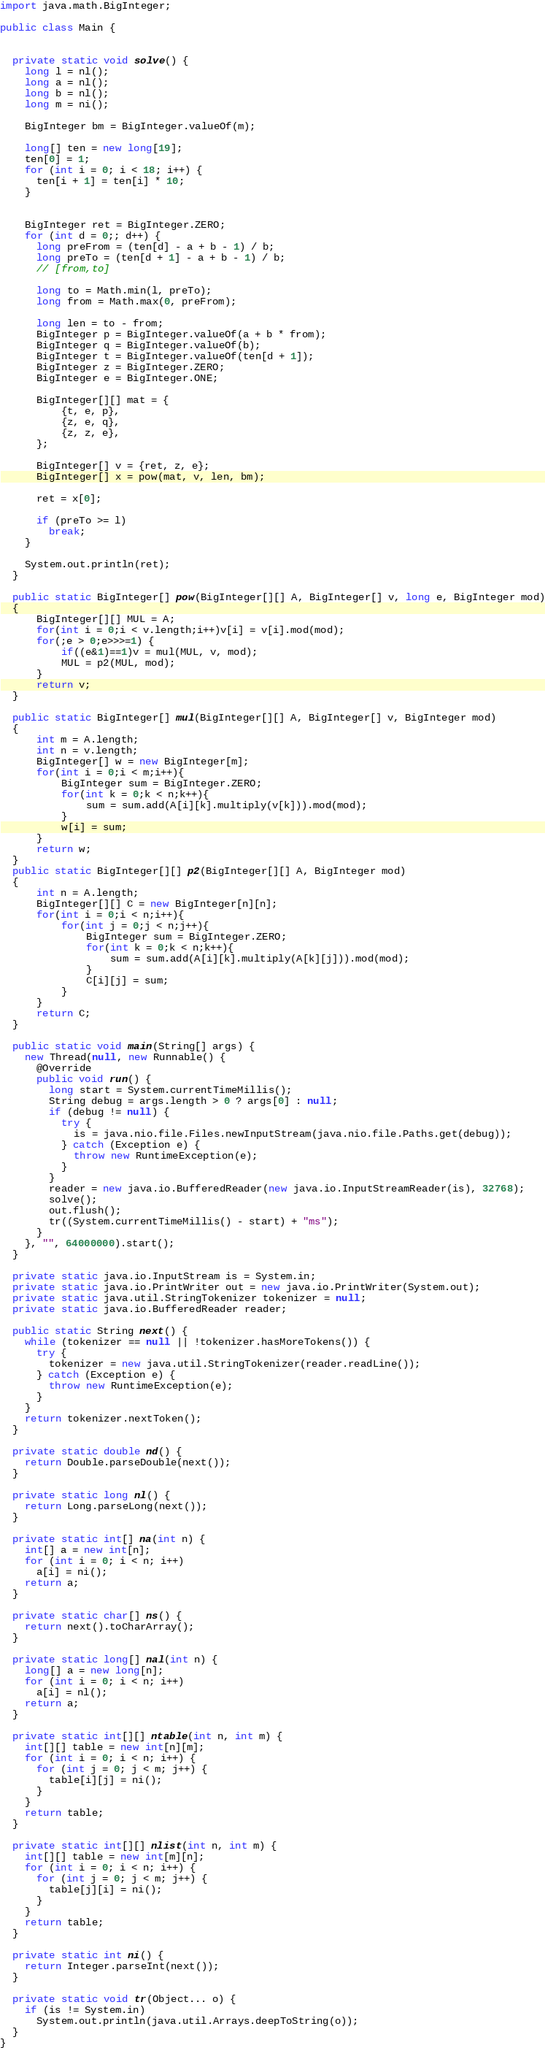Convert code to text. <code><loc_0><loc_0><loc_500><loc_500><_Java_>
import java.math.BigInteger;

public class Main {


  private static void solve() {
    long l = nl();
    long a = nl();
    long b = nl();
    long m = ni();

    BigInteger bm = BigInteger.valueOf(m);

    long[] ten = new long[19];
    ten[0] = 1;
    for (int i = 0; i < 18; i++) {
      ten[i + 1] = ten[i] * 10;
    }


    BigInteger ret = BigInteger.ZERO;
    for (int d = 0;; d++) {
      long preFrom = (ten[d] - a + b - 1) / b;
      long preTo = (ten[d + 1] - a + b - 1) / b;
      // [from,to]

      long to = Math.min(l, preTo);
      long from = Math.max(0, preFrom);

      long len = to - from;
      BigInteger p = BigInteger.valueOf(a + b * from);
      BigInteger q = BigInteger.valueOf(b);
      BigInteger t = BigInteger.valueOf(ten[d + 1]);
      BigInteger z = BigInteger.ZERO;
      BigInteger e = BigInteger.ONE;

      BigInteger[][] mat = {
          {t, e, p},
          {z, e, q},
          {z, z, e},
      };
      
      BigInteger[] v = {ret, z, e};
      BigInteger[] x = pow(mat, v, len, bm);
      
      ret = x[0];

      if (preTo >= l)
        break;
    }

    System.out.println(ret);
  }

  public static BigInteger[] pow(BigInteger[][] A, BigInteger[] v, long e, BigInteger mod)
  {
      BigInteger[][] MUL = A;
      for(int i = 0;i < v.length;i++)v[i] = v[i].mod(mod);
      for(;e > 0;e>>>=1) {
          if((e&1)==1)v = mul(MUL, v, mod);
          MUL = p2(MUL, mod);
      }
      return v;
  }
  
  public static BigInteger[] mul(BigInteger[][] A, BigInteger[] v, BigInteger mod)
  {
      int m = A.length;
      int n = v.length;
      BigInteger[] w = new BigInteger[m];
      for(int i = 0;i < m;i++){
          BigInteger sum = BigInteger.ZERO;
          for(int k = 0;k < n;k++){
              sum = sum.add(A[i][k].multiply(v[k])).mod(mod);
          }
          w[i] = sum;
      }
      return w;
  }
  public static BigInteger[][] p2(BigInteger[][] A, BigInteger mod)
  {
      int n = A.length;
      BigInteger[][] C = new BigInteger[n][n];
      for(int i = 0;i < n;i++){
          for(int j = 0;j < n;j++){
              BigInteger sum = BigInteger.ZERO;
              for(int k = 0;k < n;k++){
                  sum = sum.add(A[i][k].multiply(A[k][j])).mod(mod);
              }
              C[i][j] = sum;
          }
      }
      return C;
  }

  public static void main(String[] args) {
    new Thread(null, new Runnable() {
      @Override
      public void run() {
        long start = System.currentTimeMillis();
        String debug = args.length > 0 ? args[0] : null;
        if (debug != null) {
          try {
            is = java.nio.file.Files.newInputStream(java.nio.file.Paths.get(debug));
          } catch (Exception e) {
            throw new RuntimeException(e);
          }
        }
        reader = new java.io.BufferedReader(new java.io.InputStreamReader(is), 32768);
        solve();
        out.flush();
        tr((System.currentTimeMillis() - start) + "ms");
      }
    }, "", 64000000).start();
  }

  private static java.io.InputStream is = System.in;
  private static java.io.PrintWriter out = new java.io.PrintWriter(System.out);
  private static java.util.StringTokenizer tokenizer = null;
  private static java.io.BufferedReader reader;

  public static String next() {
    while (tokenizer == null || !tokenizer.hasMoreTokens()) {
      try {
        tokenizer = new java.util.StringTokenizer(reader.readLine());
      } catch (Exception e) {
        throw new RuntimeException(e);
      }
    }
    return tokenizer.nextToken();
  }

  private static double nd() {
    return Double.parseDouble(next());
  }

  private static long nl() {
    return Long.parseLong(next());
  }

  private static int[] na(int n) {
    int[] a = new int[n];
    for (int i = 0; i < n; i++)
      a[i] = ni();
    return a;
  }

  private static char[] ns() {
    return next().toCharArray();
  }

  private static long[] nal(int n) {
    long[] a = new long[n];
    for (int i = 0; i < n; i++)
      a[i] = nl();
    return a;
  }

  private static int[][] ntable(int n, int m) {
    int[][] table = new int[n][m];
    for (int i = 0; i < n; i++) {
      for (int j = 0; j < m; j++) {
        table[i][j] = ni();
      }
    }
    return table;
  }

  private static int[][] nlist(int n, int m) {
    int[][] table = new int[m][n];
    for (int i = 0; i < n; i++) {
      for (int j = 0; j < m; j++) {
        table[j][i] = ni();
      }
    }
    return table;
  }

  private static int ni() {
    return Integer.parseInt(next());
  }

  private static void tr(Object... o) {
    if (is != System.in)
      System.out.println(java.util.Arrays.deepToString(o));
  }
}
</code> 